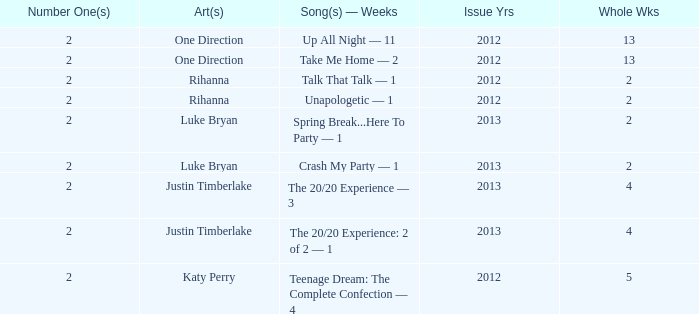What is the title of every song, and how many weeks was each song at #1 for Rihanna in 2012? Talk That Talk — 1, Unapologetic — 1. 